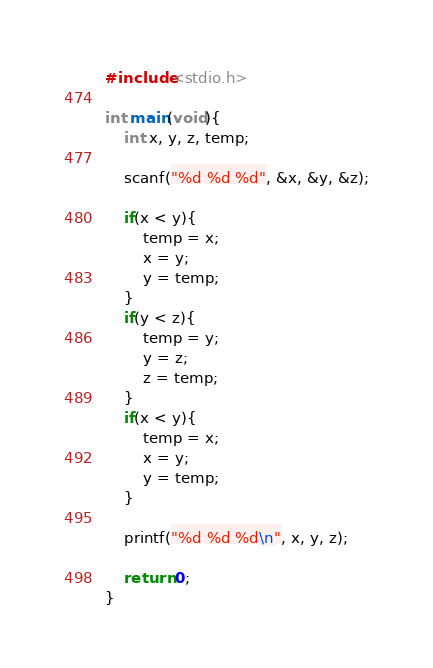Convert code to text. <code><loc_0><loc_0><loc_500><loc_500><_C_>#include<stdio.h>

int main(void){
    int x, y, z, temp;

    scanf("%d %d %d", &x, &y, &z);

    if(x < y){
        temp = x;
        x = y;
        y = temp;
    }
    if(y < z){
        temp = y;
        y = z;
        z = temp;
    }
    if(x < y){
        temp = x;
        x = y;
        y = temp;
    }

    printf("%d %d %d\n", x, y, z);

    return 0;
}</code> 